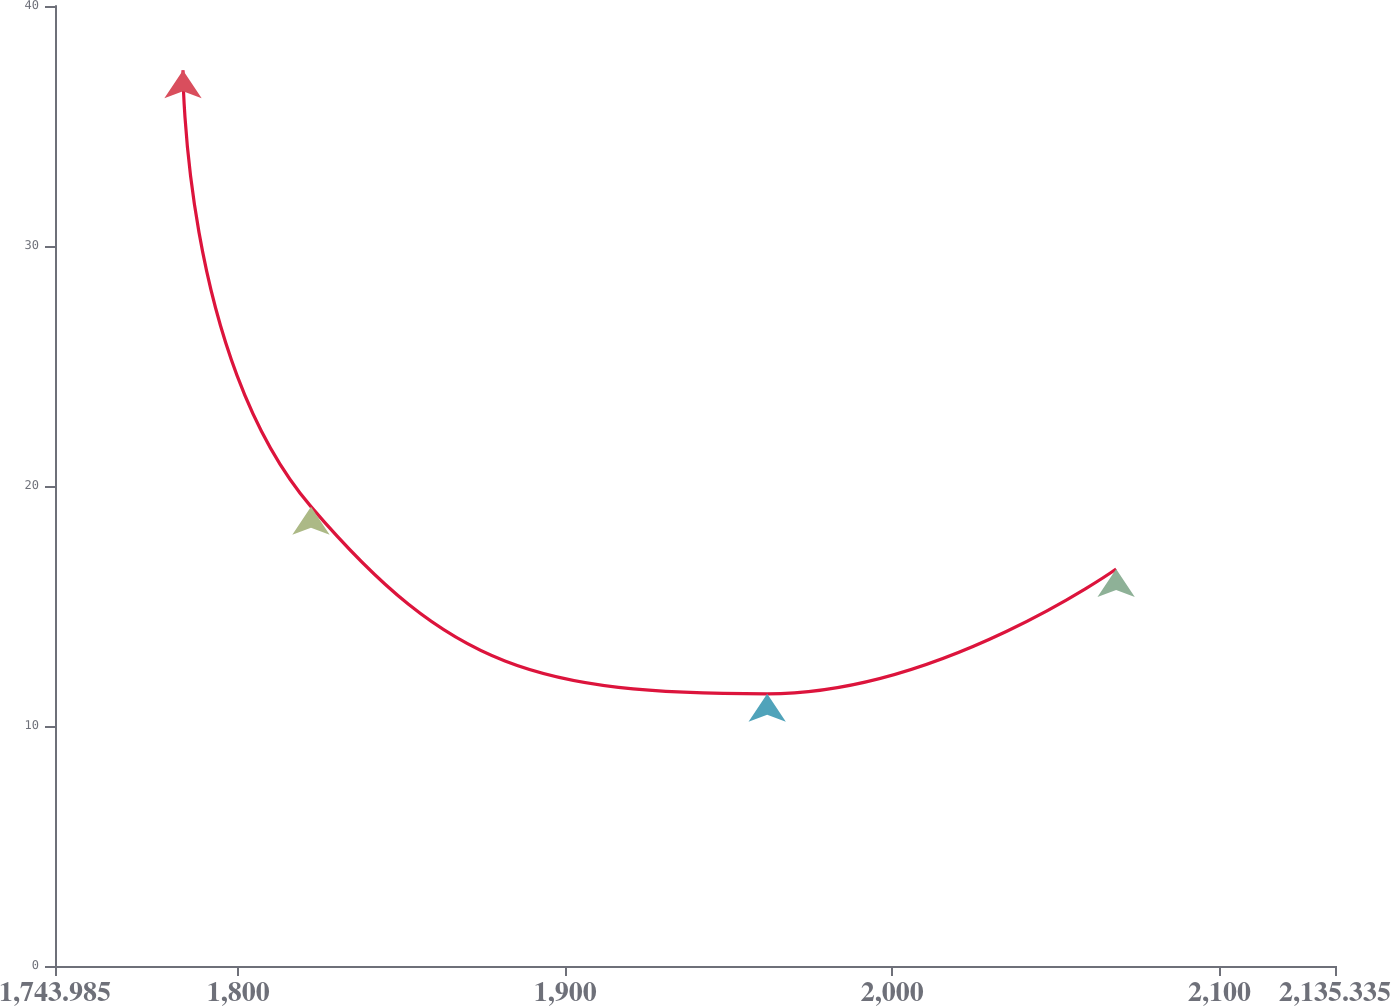<chart> <loc_0><loc_0><loc_500><loc_500><line_chart><ecel><fcel>Unnamed: 1<nl><fcel>1783.12<fcel>37.32<nl><fcel>1822.25<fcel>19.14<nl><fcel>1961.73<fcel>11.34<nl><fcel>2068.42<fcel>16.54<nl><fcel>2174.47<fcel>13.94<nl></chart> 